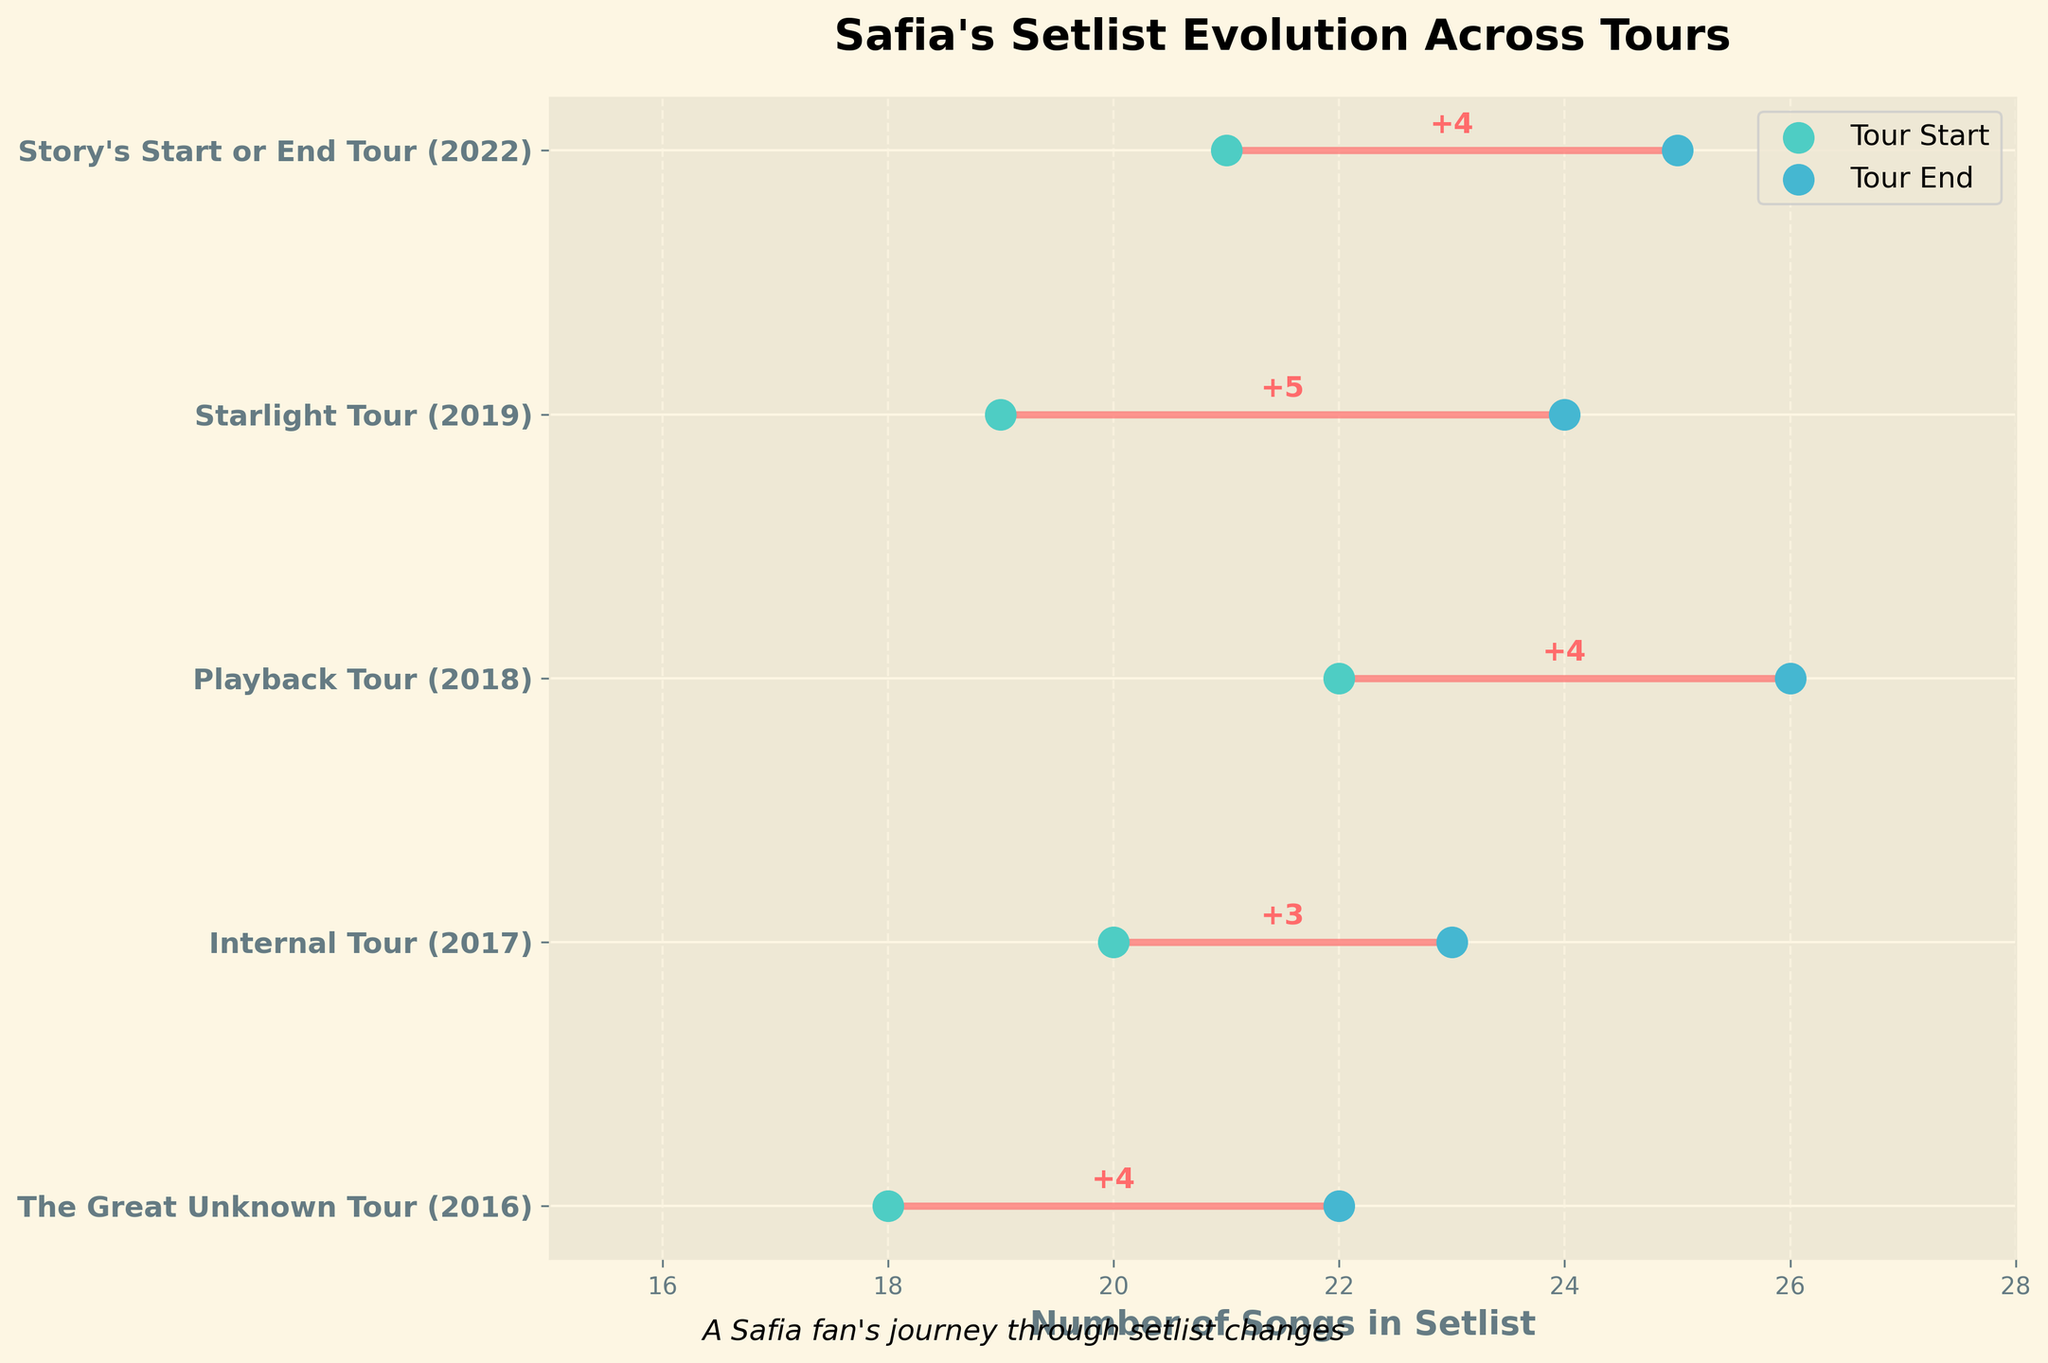How many tours are displayed in the plot? Count the number of unique tours listed on the y-axis. There are 5 tours displayed.
Answer: 5 What is the title of the plot? The title of the plot is displayed at the top. It reads "Safia's Setlist Evolution Across Tours".
Answer: Safia's Setlist Evolution Across Tours Which tour had the highest number of setlist changes? Look at the annotations next to the lines. The "Starlight Tour (2019)" had 5 changes, which is the highest.
Answer: Starlight Tour (2019) What are the colors representing the start and end points of the tours? Observe the colors of the dots at the line's start and end. Start points are in turquoise and end points are in blue.
Answer: Turquoise and Blue What's the average number of setlist changes across all tours? Add all the setlist changes and divide by the number of tours: (4 + 3 + 4 + 5 + 4) / 5 = 4.
Answer: 4 Which tour's setlist changed the least from start to end? Compare the annotations for setlist changes. The "Internal Tour (2017)" had the least changes with 3.
Answer: Internal Tour (2017) Which tour started with the smallest number of songs in the setlist? Look at the number on the left side of the lines. The "The Great Unknown Tour (2016)" started with 18 songs.
Answer: The Great Unknown Tour (2016) What is the range of the number of songs in the setlist for the "Playback Tour (2018)"? Subtract the starting number of songs from the ending number: 26 - 22 = 4.
Answer: 4 How much more did the setlist change for the "Playback Tour (2018)" compared to the "Internal Tour (2017)"? Subtract the number of changes in 2017 from the number in 2018: 4 - 3 = 1.
Answer: 1 Which tours had exactly four setlist changes? Identifying the tours with "+4" annotation. The tours are "The Great Unknown Tour (2016)", "Playback Tour (2018)", and "Story's Start or End Tour (2022)".
Answer: The Great Unknown Tour (2016), Playback Tour (2018), Story's Start or End Tour (2022) 